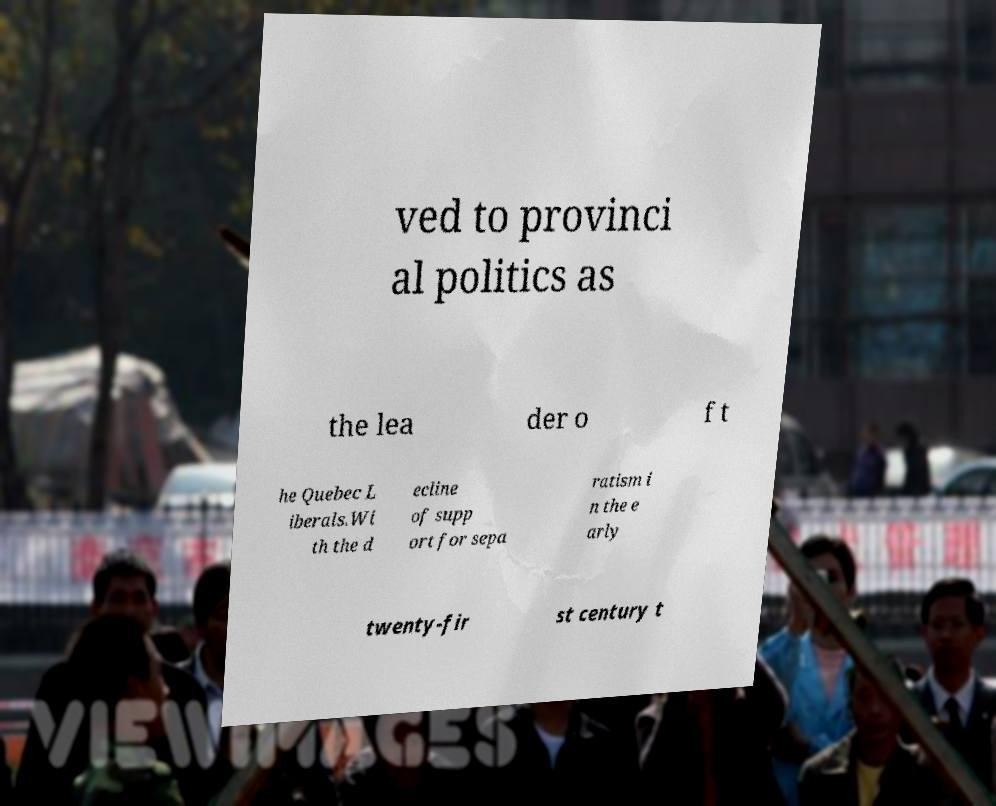Can you accurately transcribe the text from the provided image for me? ved to provinci al politics as the lea der o f t he Quebec L iberals.Wi th the d ecline of supp ort for sepa ratism i n the e arly twenty-fir st century t 